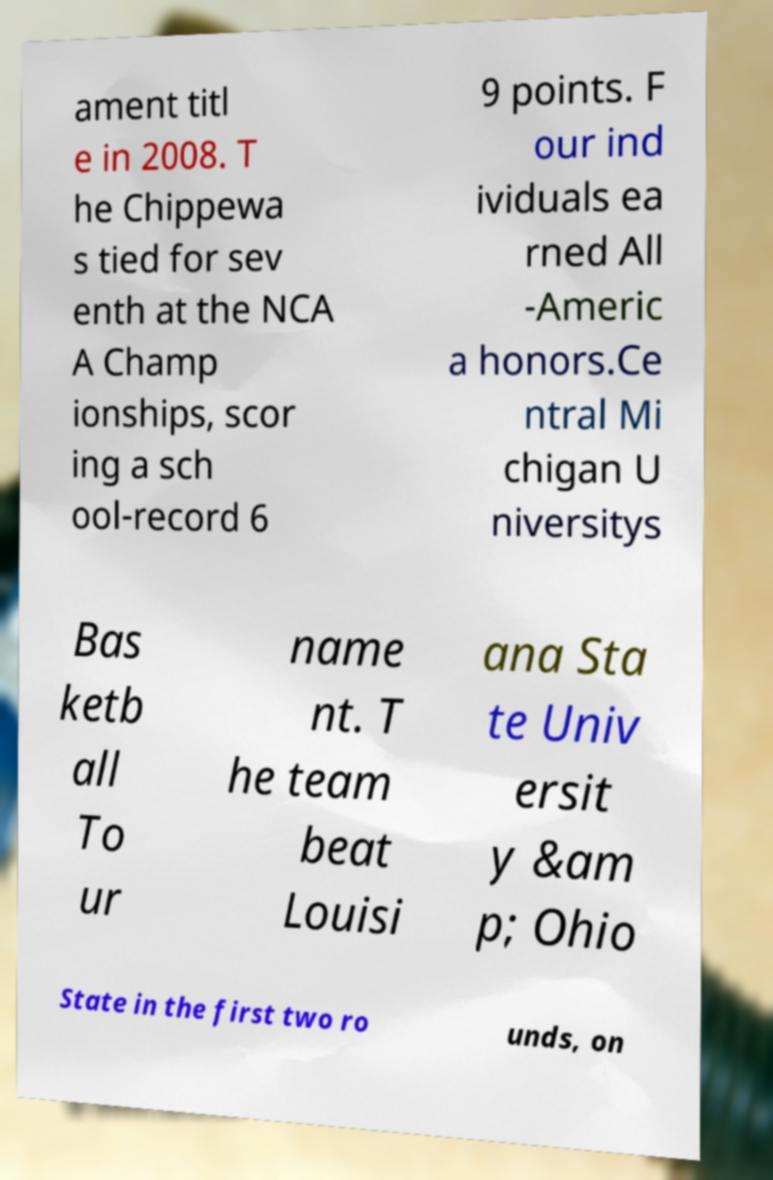Could you extract and type out the text from this image? ament titl e in 2008. T he Chippewa s tied for sev enth at the NCA A Champ ionships, scor ing a sch ool-record 6 9 points. F our ind ividuals ea rned All -Americ a honors.Ce ntral Mi chigan U niversitys Bas ketb all To ur name nt. T he team beat Louisi ana Sta te Univ ersit y &am p; Ohio State in the first two ro unds, on 